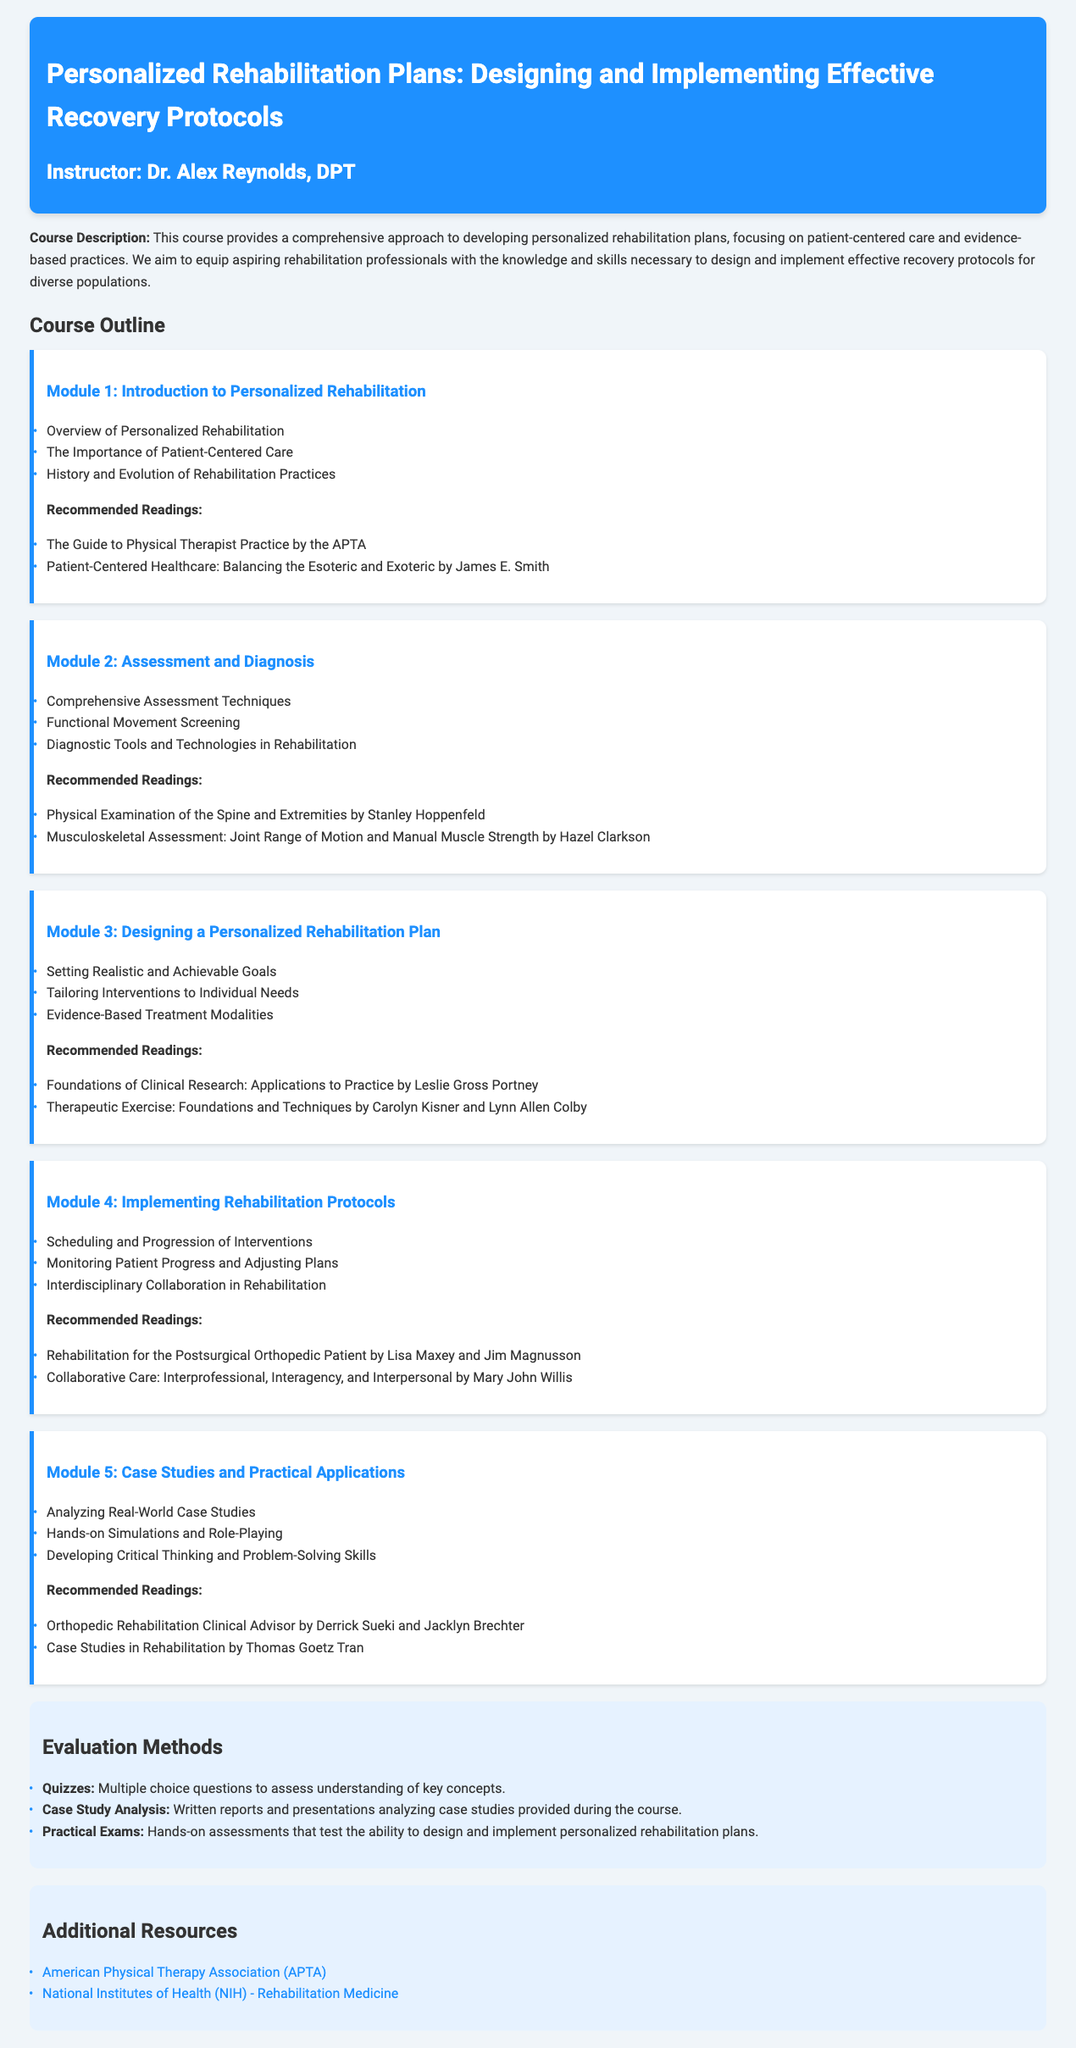What is the title of the course? The title of the course is stated at the top of the document, which is "Personalized Rehabilitation Plans: Designing and Implementing Effective Recovery Protocols."
Answer: Personalized Rehabilitation Plans: Designing and Implementing Effective Recovery Protocols Who is the instructor of the course? The instructor's name is mentioned in the header section of the syllabus.
Answer: Dr. Alex Reynolds, DPT What is the focus of Module 1? Module 1 covers the introductory topics related to personalized rehabilitation, including patient-centered care.
Answer: Introduction to Personalized Rehabilitation How many modules are outlined in the syllabus? By counting the modules listed in the course outline, we can determine the total number.
Answer: 5 What type of evaluation method is used for assessing understanding? The syllabus specifies multiple choice questions as one of the evaluation methods.
Answer: Quizzes Which recommended reading focuses on assessment techniques? The recommended readings include specific texts, and one of them focuses on physical examination, which pertains to assessment techniques.
Answer: Physical Examination of the Spine and Extremities by Stanley Hoppenfeld What does Module 5 emphasize in its content? The content of Module 5 revolves around practical applications, such as case studies and simulations.
Answer: Case Studies and Practical Applications Name one organization listed in the additional resources. The document includes two organizations as resources, one of which is the American Physical Therapy Association.
Answer: American Physical Therapy Association (APTA) 